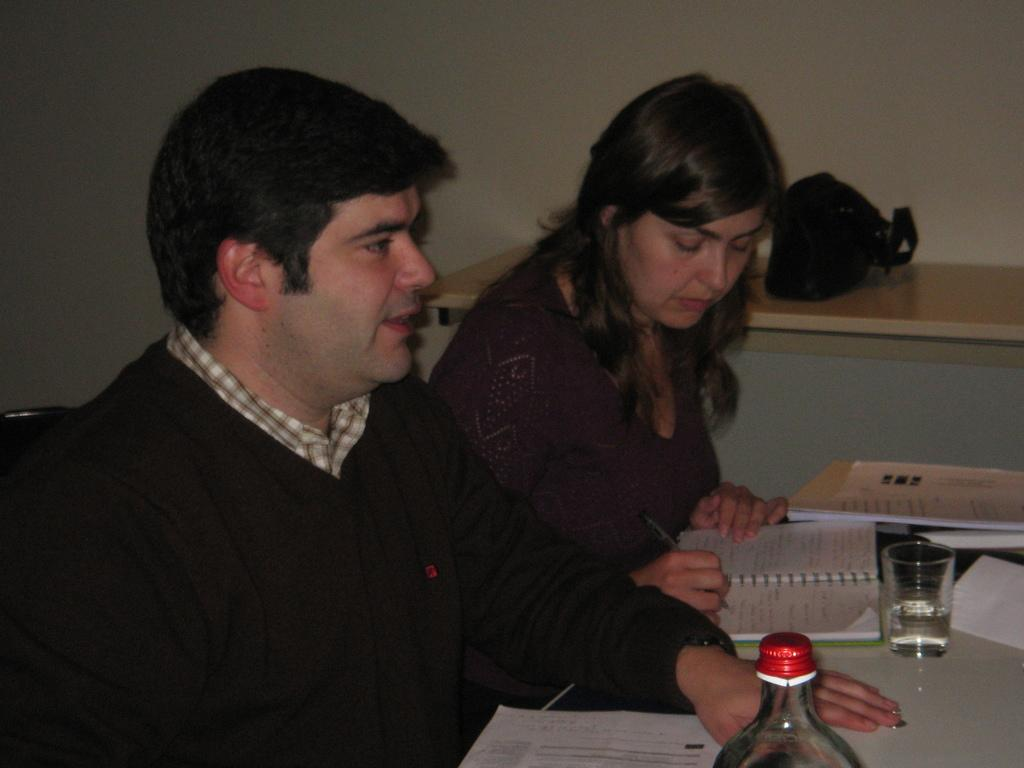How many people are present in the image? There are two people sitting in the image. What is the person on the right doing? The person on the right is writing in a diary. What objects can be seen on the table? There is a glass and a bottle on the table. What type of smoke is coming from the ant in the image? There is no ant or smoke present in the image. How does the ray interact with the objects on the table? There is no ray present in the image; it only features two people and objects on the table. 